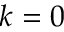<formula> <loc_0><loc_0><loc_500><loc_500>k = 0</formula> 